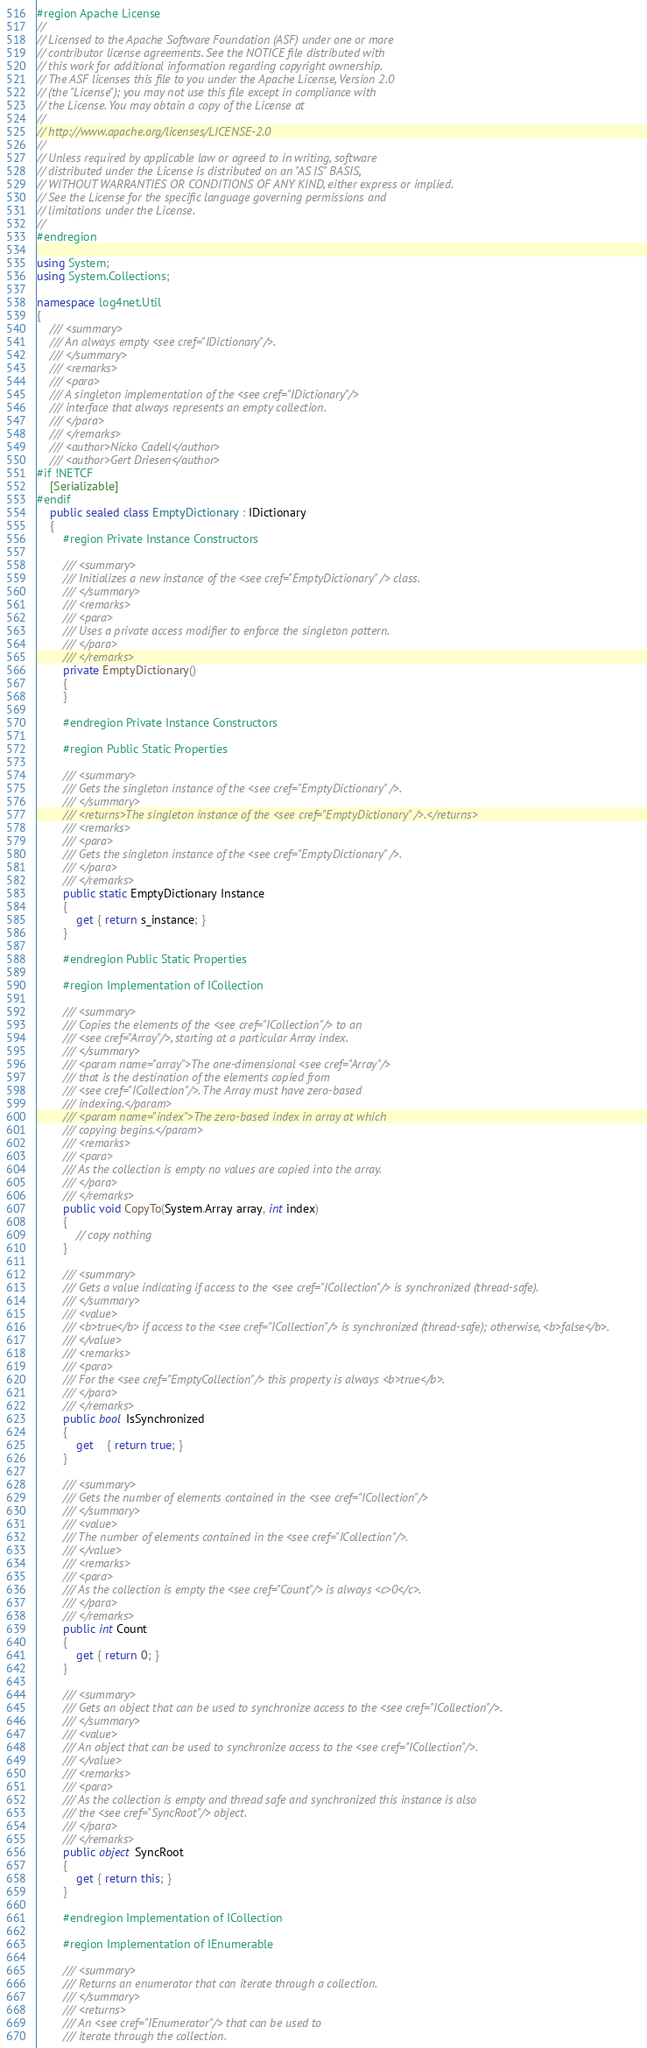<code> <loc_0><loc_0><loc_500><loc_500><_C#_>#region Apache License
//
// Licensed to the Apache Software Foundation (ASF) under one or more 
// contributor license agreements. See the NOTICE file distributed with
// this work for additional information regarding copyright ownership. 
// The ASF licenses this file to you under the Apache License, Version 2.0
// (the "License"); you may not use this file except in compliance with 
// the License. You may obtain a copy of the License at
//
// http://www.apache.org/licenses/LICENSE-2.0
//
// Unless required by applicable law or agreed to in writing, software
// distributed under the License is distributed on an "AS IS" BASIS,
// WITHOUT WARRANTIES OR CONDITIONS OF ANY KIND, either express or implied.
// See the License for the specific language governing permissions and
// limitations under the License.
//
#endregion

using System;
using System.Collections;

namespace log4net.Util
{
	/// <summary>
	/// An always empty <see cref="IDictionary"/>.
	/// </summary>
	/// <remarks>
	/// <para>
	/// A singleton implementation of the <see cref="IDictionary"/>
	/// interface that always represents an empty collection.
	/// </para>
	/// </remarks>
	/// <author>Nicko Cadell</author>
	/// <author>Gert Driesen</author>
#if !NETCF
	[Serializable]
#endif
	public sealed class EmptyDictionary : IDictionary
	{
		#region Private Instance Constructors

		/// <summary>
		/// Initializes a new instance of the <see cref="EmptyDictionary" /> class. 
		/// </summary>
		/// <remarks>
		/// <para>
		/// Uses a private access modifier to enforce the singleton pattern.
		/// </para>
		/// </remarks>
		private EmptyDictionary()
		{
		}

		#endregion Private Instance Constructors
  
		#region Public Static Properties

		/// <summary>
		/// Gets the singleton instance of the <see cref="EmptyDictionary" />.
		/// </summary>
		/// <returns>The singleton instance of the <see cref="EmptyDictionary" />.</returns>
		/// <remarks>
		/// <para>
		/// Gets the singleton instance of the <see cref="EmptyDictionary" />.
		/// </para>
		/// </remarks>
		public static EmptyDictionary Instance
		{
			get { return s_instance; }
		}

		#endregion Public Static Properties

		#region Implementation of ICollection

		/// <summary>
		/// Copies the elements of the <see cref="ICollection"/> to an 
		/// <see cref="Array"/>, starting at a particular Array index.
		/// </summary>
		/// <param name="array">The one-dimensional <see cref="Array"/> 
		/// that is the destination of the elements copied from 
		/// <see cref="ICollection"/>. The Array must have zero-based 
		/// indexing.</param>
		/// <param name="index">The zero-based index in array at which 
		/// copying begins.</param>
		/// <remarks>
		/// <para>
		/// As the collection is empty no values are copied into the array.
		/// </para>
		/// </remarks>
		public void CopyTo(System.Array array, int index)
		{
			// copy nothing
		}

		/// <summary>
		/// Gets a value indicating if access to the <see cref="ICollection"/> is synchronized (thread-safe).
		/// </summary>
		/// <value>
		/// <b>true</b> if access to the <see cref="ICollection"/> is synchronized (thread-safe); otherwise, <b>false</b>.
		/// </value>
		/// <remarks>
		/// <para>
		/// For the <see cref="EmptyCollection"/> this property is always <b>true</b>.
		/// </para>
		/// </remarks>
		public bool IsSynchronized
		{
			get	{ return true; }
		}

		/// <summary>
		/// Gets the number of elements contained in the <see cref="ICollection"/>
		/// </summary>
		/// <value>
		/// The number of elements contained in the <see cref="ICollection"/>.
		/// </value>
		/// <remarks>
		/// <para>
		/// As the collection is empty the <see cref="Count"/> is always <c>0</c>.
		/// </para>
		/// </remarks>
		public int Count
		{
			get { return 0; }
		}

		/// <summary>
		/// Gets an object that can be used to synchronize access to the <see cref="ICollection"/>.
		/// </summary>
		/// <value>
		/// An object that can be used to synchronize access to the <see cref="ICollection"/>.
		/// </value>
		/// <remarks>
		/// <para>
		/// As the collection is empty and thread safe and synchronized this instance is also
		/// the <see cref="SyncRoot"/> object.
		/// </para>
		/// </remarks>
		public object SyncRoot
		{
			get { return this; }
		}

		#endregion Implementation of ICollection

		#region Implementation of IEnumerable

		/// <summary>
		/// Returns an enumerator that can iterate through a collection.
		/// </summary>
		/// <returns>
		/// An <see cref="IEnumerator"/> that can be used to 
		/// iterate through the collection.</code> 